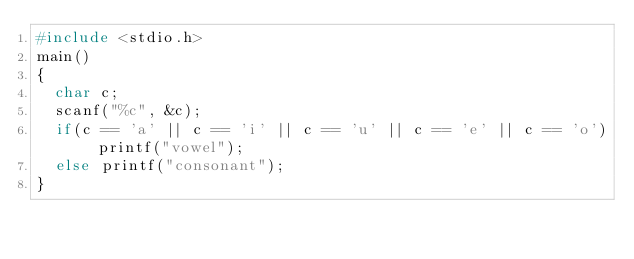<code> <loc_0><loc_0><loc_500><loc_500><_C_>#include <stdio.h>
main()
{
  char c;
  scanf("%c", &c);
  if(c == 'a' || c == 'i' || c == 'u' || c == 'e' || c == 'o') printf("vowel");
  else printf("consonant");
}
</code> 